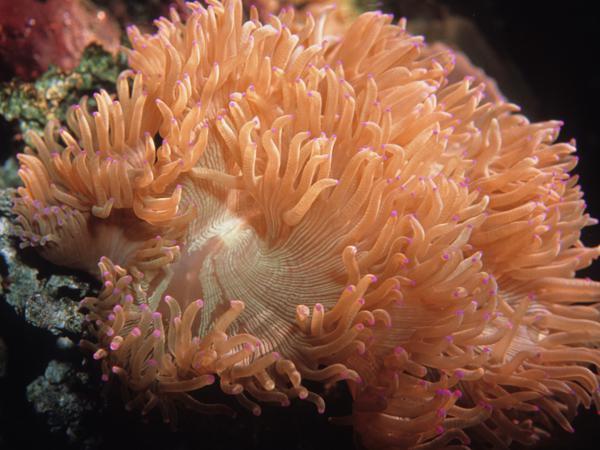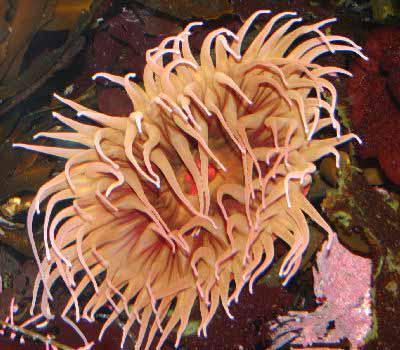The first image is the image on the left, the second image is the image on the right. Considering the images on both sides, is "There is no more than one pink anemone." valid? Answer yes or no. No. 